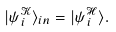Convert formula to latex. <formula><loc_0><loc_0><loc_500><loc_500>| \psi _ { i } ^ { \mathcal { K } } \rangle _ { i n } = | \psi _ { i } ^ { \mathcal { H } } \rangle .</formula> 